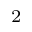Convert formula to latex. <formula><loc_0><loc_0><loc_500><loc_500>^ { 2 }</formula> 